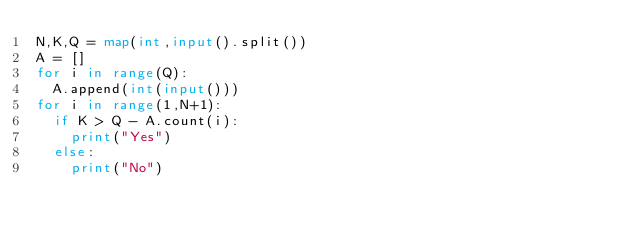<code> <loc_0><loc_0><loc_500><loc_500><_Python_>N,K,Q = map(int,input().split())
A = []
for i in range(Q):
  A.append(int(input()))
for i in range(1,N+1):
  if K > Q - A.count(i):
    print("Yes")
  else:
    print("No")</code> 